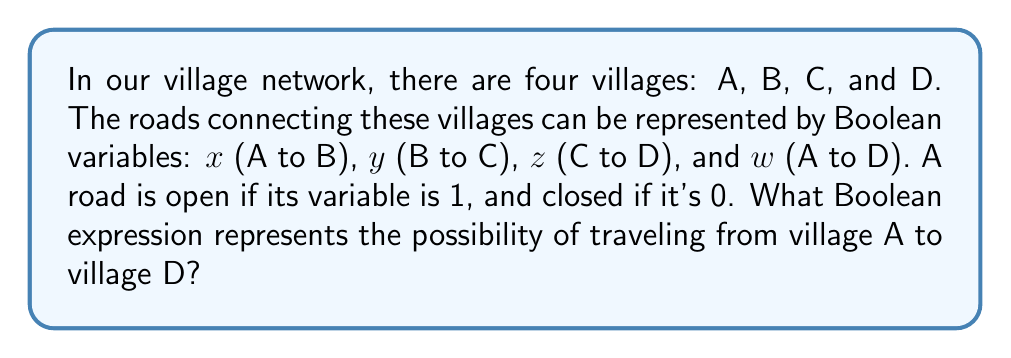Teach me how to tackle this problem. To solve this problem, we need to consider all possible routes from village A to village D:

1. Direct route: A to D (represented by $w$)
2. Indirect route: A to B to C to D (represented by $x \cdot y \cdot z$)

The Boolean expression for the possibility of traveling from A to D is the logical OR of these two routes:

$$ f(x,y,z,w) = w + (x \cdot y \cdot z) $$

This expression can be interpreted as:
- We can travel from A to D if:
  a) The direct road from A to D is open (w = 1), OR
  b) All roads in the path A → B → C → D are open (x = 1 AND y = 1 AND z = 1)

To simplify this expression, we can use the distributive property of Boolean algebra:

$$ f(x,y,z,w) = w + xyz $$

This simplified expression represents the most efficient Boolean representation of the possible routes between villages A and D.
Answer: $w + xyz$ 